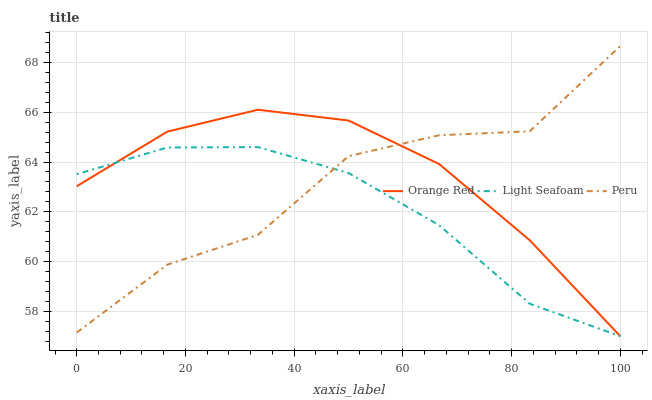Does Light Seafoam have the minimum area under the curve?
Answer yes or no. Yes. Does Orange Red have the maximum area under the curve?
Answer yes or no. Yes. Does Peru have the minimum area under the curve?
Answer yes or no. No. Does Peru have the maximum area under the curve?
Answer yes or no. No. Is Orange Red the smoothest?
Answer yes or no. Yes. Is Peru the roughest?
Answer yes or no. Yes. Is Peru the smoothest?
Answer yes or no. No. Is Orange Red the roughest?
Answer yes or no. No. Does Light Seafoam have the lowest value?
Answer yes or no. Yes. Does Peru have the lowest value?
Answer yes or no. No. Does Peru have the highest value?
Answer yes or no. Yes. Does Orange Red have the highest value?
Answer yes or no. No. Does Peru intersect Light Seafoam?
Answer yes or no. Yes. Is Peru less than Light Seafoam?
Answer yes or no. No. Is Peru greater than Light Seafoam?
Answer yes or no. No. 